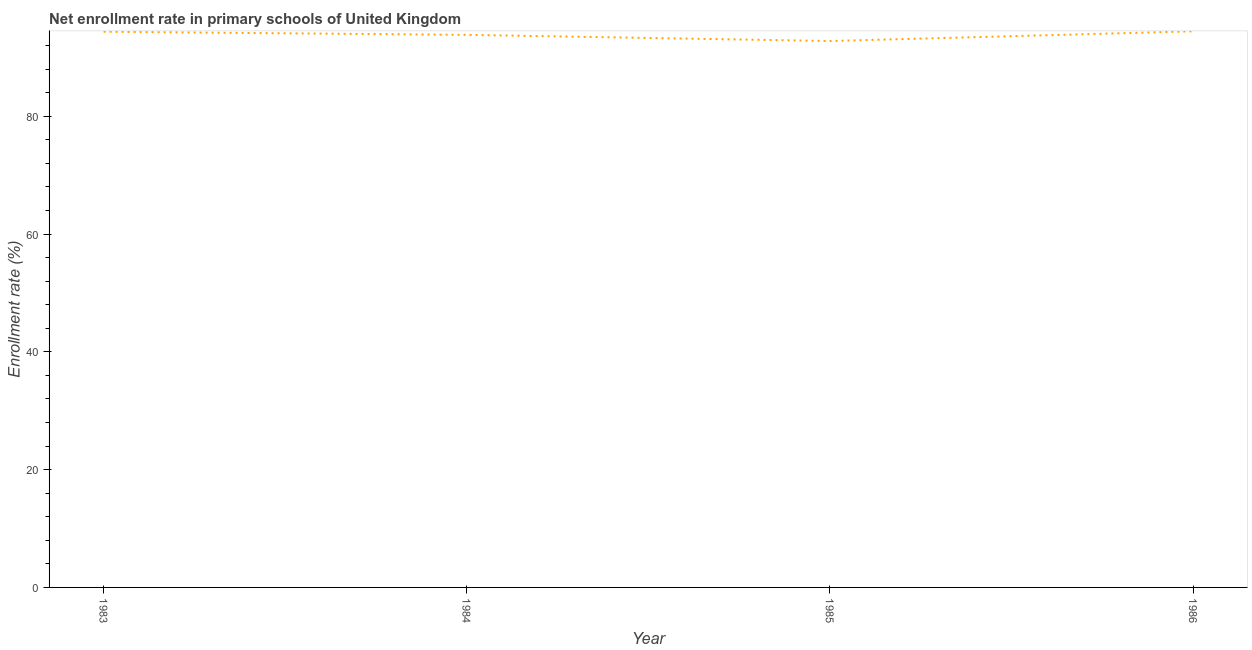What is the net enrollment rate in primary schools in 1983?
Offer a very short reply. 94.34. Across all years, what is the maximum net enrollment rate in primary schools?
Your response must be concise. 94.42. Across all years, what is the minimum net enrollment rate in primary schools?
Make the answer very short. 92.77. In which year was the net enrollment rate in primary schools maximum?
Provide a short and direct response. 1986. What is the sum of the net enrollment rate in primary schools?
Ensure brevity in your answer.  375.35. What is the difference between the net enrollment rate in primary schools in 1983 and 1985?
Your answer should be very brief. 1.58. What is the average net enrollment rate in primary schools per year?
Your response must be concise. 93.84. What is the median net enrollment rate in primary schools?
Your answer should be compact. 94.08. What is the ratio of the net enrollment rate in primary schools in 1983 to that in 1985?
Your response must be concise. 1.02. What is the difference between the highest and the second highest net enrollment rate in primary schools?
Offer a terse response. 0.07. Is the sum of the net enrollment rate in primary schools in 1983 and 1985 greater than the maximum net enrollment rate in primary schools across all years?
Keep it short and to the point. Yes. What is the difference between the highest and the lowest net enrollment rate in primary schools?
Provide a succinct answer. 1.65. How many lines are there?
Provide a succinct answer. 1. What is the difference between two consecutive major ticks on the Y-axis?
Provide a short and direct response. 20. Are the values on the major ticks of Y-axis written in scientific E-notation?
Offer a terse response. No. Does the graph contain grids?
Your answer should be compact. No. What is the title of the graph?
Offer a very short reply. Net enrollment rate in primary schools of United Kingdom. What is the label or title of the X-axis?
Give a very brief answer. Year. What is the label or title of the Y-axis?
Your answer should be very brief. Enrollment rate (%). What is the Enrollment rate (%) of 1983?
Ensure brevity in your answer.  94.34. What is the Enrollment rate (%) in 1984?
Ensure brevity in your answer.  93.82. What is the Enrollment rate (%) of 1985?
Offer a very short reply. 92.77. What is the Enrollment rate (%) in 1986?
Keep it short and to the point. 94.42. What is the difference between the Enrollment rate (%) in 1983 and 1984?
Ensure brevity in your answer.  0.53. What is the difference between the Enrollment rate (%) in 1983 and 1985?
Make the answer very short. 1.58. What is the difference between the Enrollment rate (%) in 1983 and 1986?
Provide a succinct answer. -0.07. What is the difference between the Enrollment rate (%) in 1984 and 1985?
Your answer should be compact. 1.05. What is the difference between the Enrollment rate (%) in 1984 and 1986?
Your response must be concise. -0.6. What is the difference between the Enrollment rate (%) in 1985 and 1986?
Offer a terse response. -1.65. What is the ratio of the Enrollment rate (%) in 1983 to that in 1985?
Give a very brief answer. 1.02. What is the ratio of the Enrollment rate (%) in 1983 to that in 1986?
Provide a succinct answer. 1. What is the ratio of the Enrollment rate (%) in 1984 to that in 1986?
Make the answer very short. 0.99. What is the ratio of the Enrollment rate (%) in 1985 to that in 1986?
Provide a succinct answer. 0.98. 